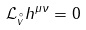<formula> <loc_0><loc_0><loc_500><loc_500>\mathcal { L } _ { \stackrel { \circ } v } h ^ { \mu \nu } = 0</formula> 